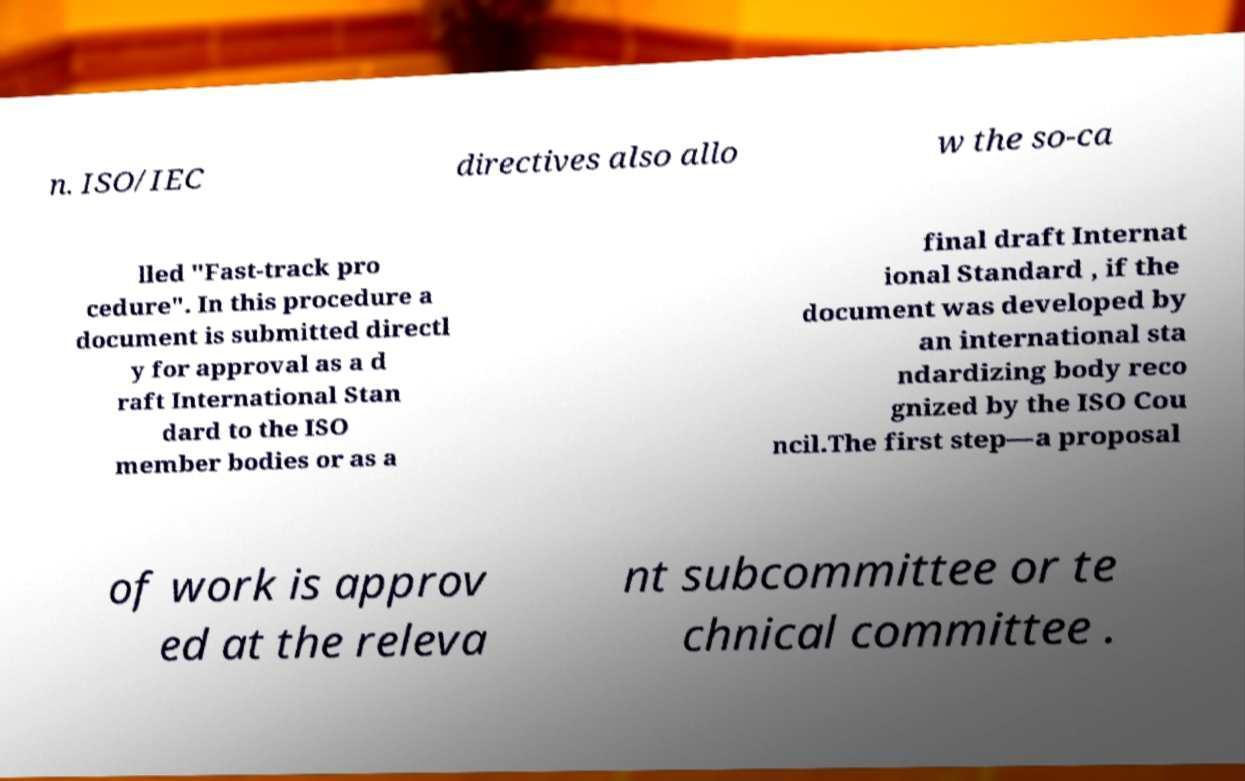I need the written content from this picture converted into text. Can you do that? n. ISO/IEC directives also allo w the so-ca lled "Fast-track pro cedure". In this procedure a document is submitted directl y for approval as a d raft International Stan dard to the ISO member bodies or as a final draft Internat ional Standard , if the document was developed by an international sta ndardizing body reco gnized by the ISO Cou ncil.The first step—a proposal of work is approv ed at the releva nt subcommittee or te chnical committee . 